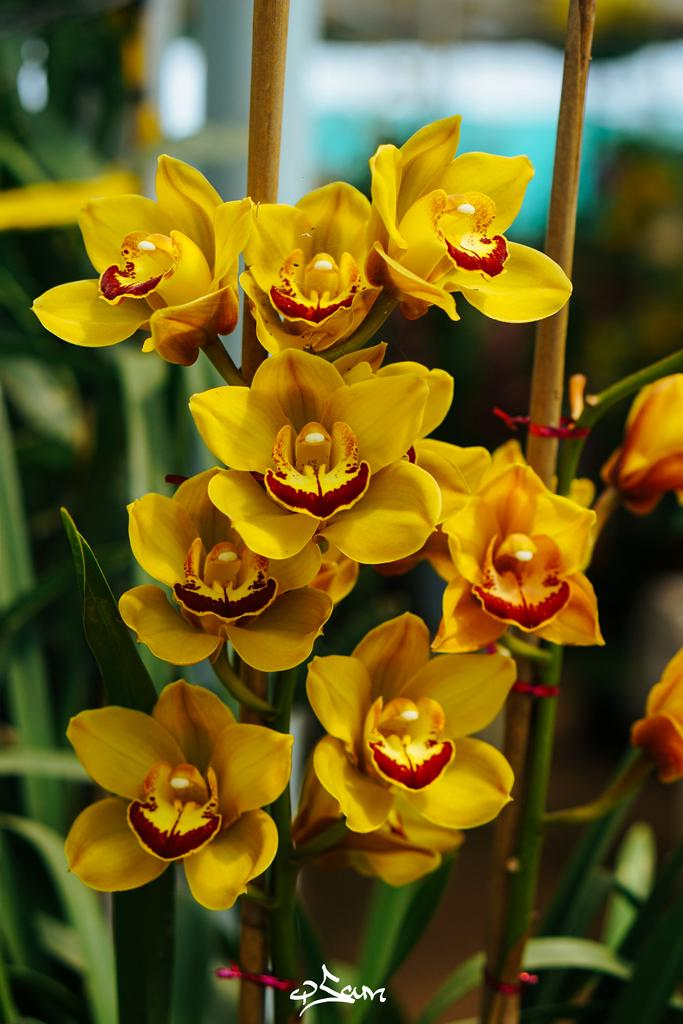What type of plants are in the image? There are flowers in the image. What color are the flowers? The flowers are yellow in color. What else can be seen at the bottom of the image? There are leaves at the bottom of the image. What type of metal is used to create the servant in the image? There is no servant present in the image, and therefore no metal can be associated with it. 